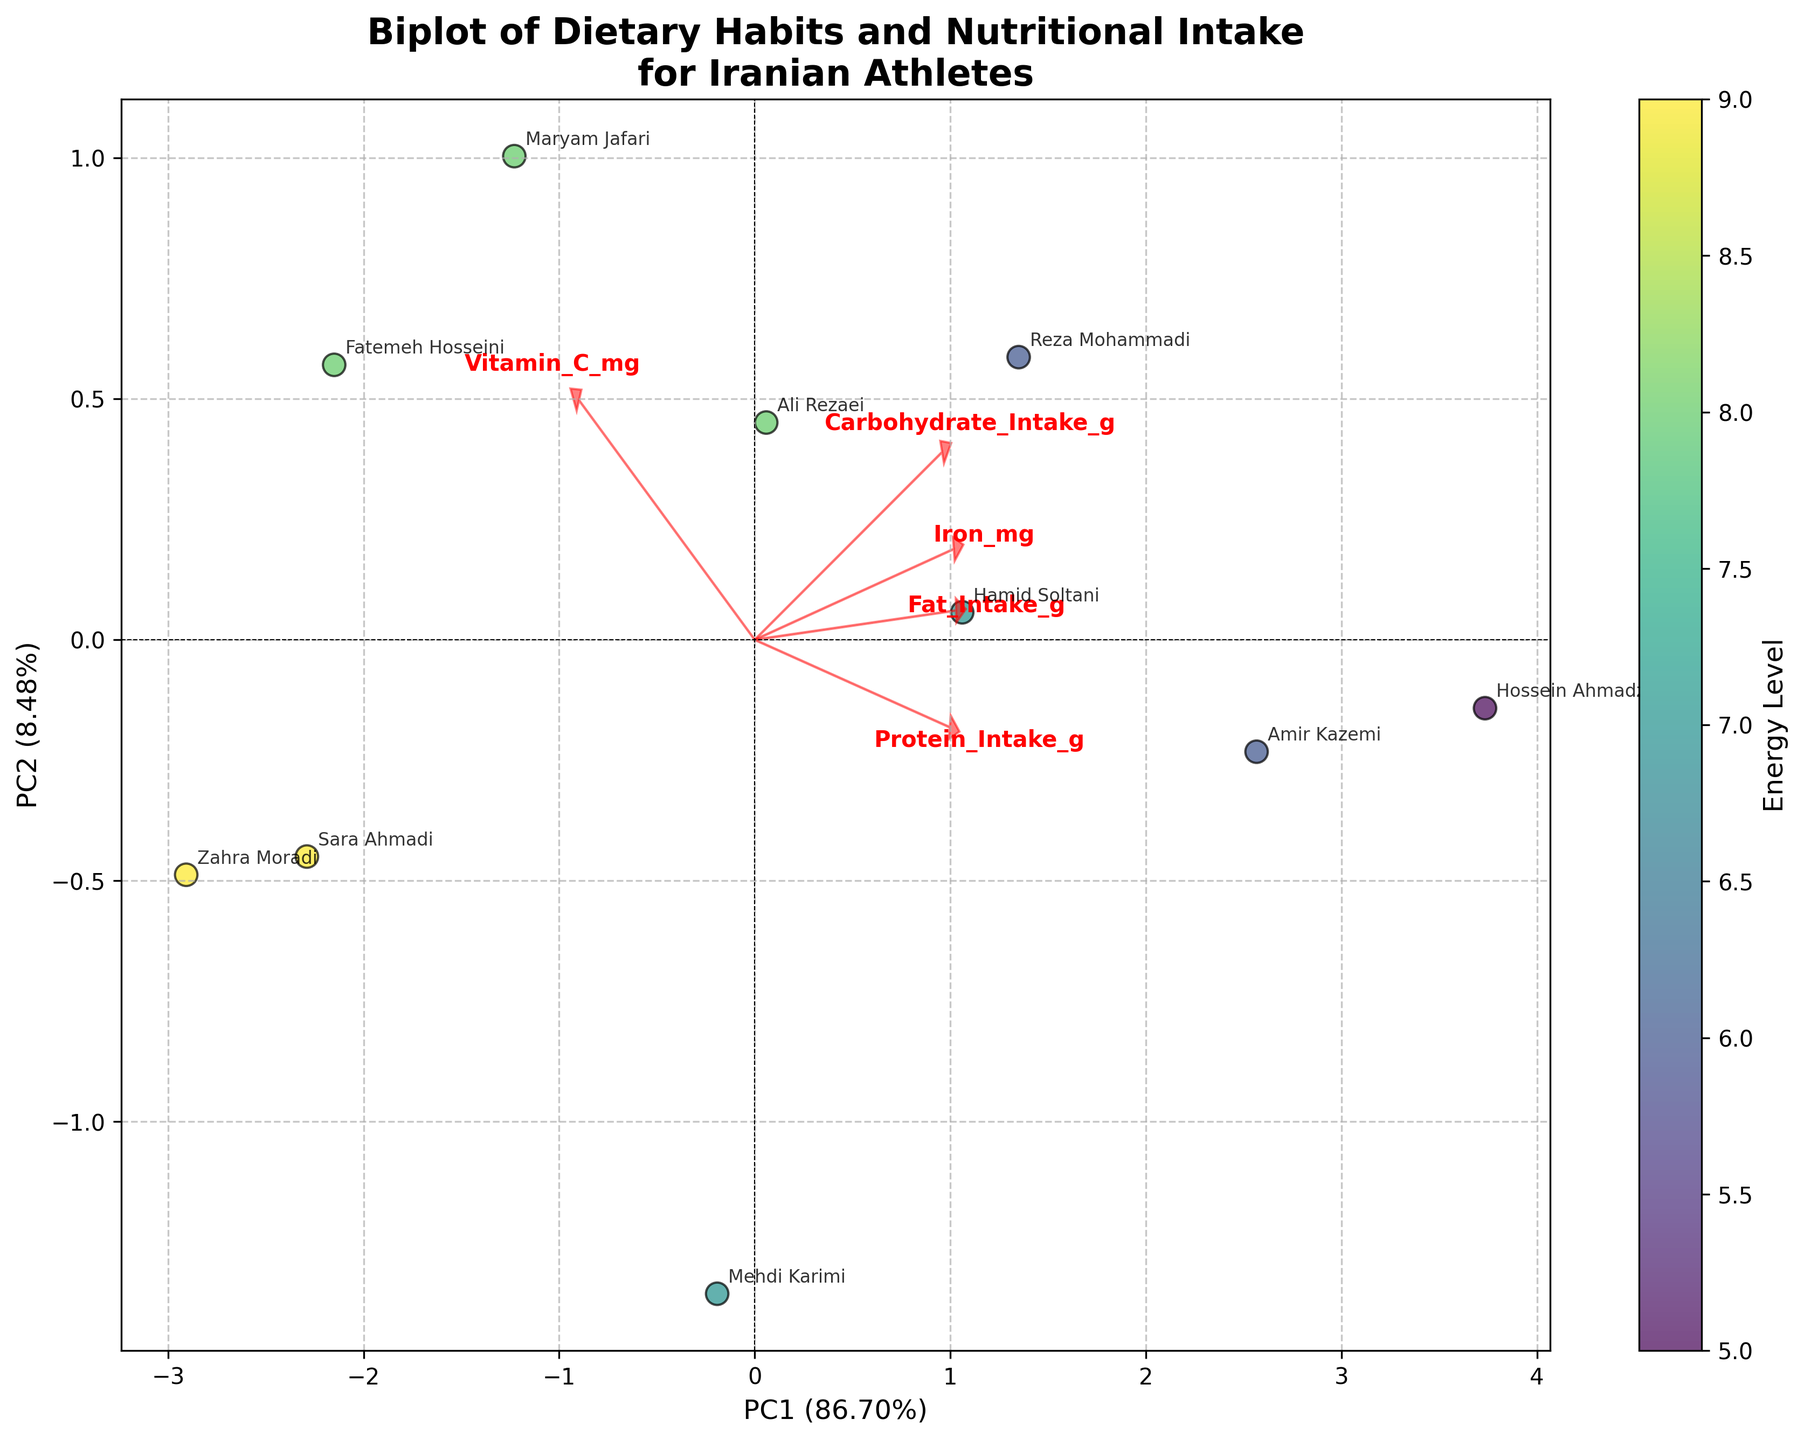What is the title of the plot? Look at the top of the plot where the title is usually placed.
Answer: Biplot of Dietary Habits and Nutritional Intake for Iranian Athletes How many athletes are represented in the plot? Count the number of data points, which are usually shown as dots on the scatter plot.
Answer: 10 Which two nutrients have the largest vectors? Look for the features represented by arrows with the longest lengths from the origin.
Answer: Protein_Intake_g and Fat_Intake_g Which athlete has the highest energy level? Use the color scale and look for the darkest colored data point, then check the annotation for the athlete's name.
Answer: Sara Ahmadi and Zahra Moradi What is the relationship between Carbohydrate_Intake_g and the first principal component (PC1)? Observe the direction and length of the Carbohydrate_Intake_g arrow relative to the PC1 axis.
Answer: Strong positive correlation Which direction does the Iron_mg vector point? Examine the arrow labeled Iron_mg and note its direction.
Answer: Positive PC1 and slightly positive PC2 What is the explained variance by PC1 and PC2 combined? Look at the axis labels for PC1 and PC2, sum the percentages shown in parentheses.
Answer: About 79% Is there a visible correlation between Vitamin_C_mg intake and Match_Duration_min based on the figure? Observe the plot and check the placement of data points with high Vitamin_C_mg levels in relation to their Match_Duration_min values.
Answer: Not clearly visible Which nutrient has a vector pointing in the direction opposite to PC1? Identify the arrow whose direction is contrary to PC1.
Answer: None of the nutrients have a vector pointing opposite to PC1 